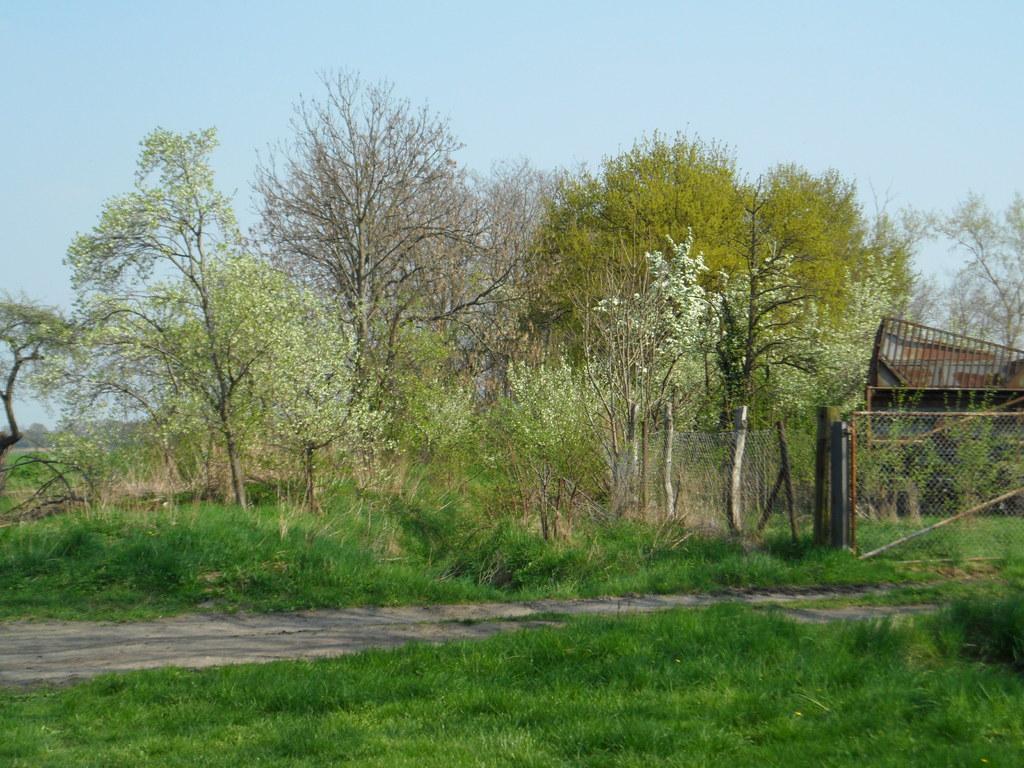Can you describe this image briefly? This picture is clicked outside. In the foreground we can see the green grass. In the center we can see the trees, flowers, metal rods, mesh and a shed. In the background we can see the sky. 